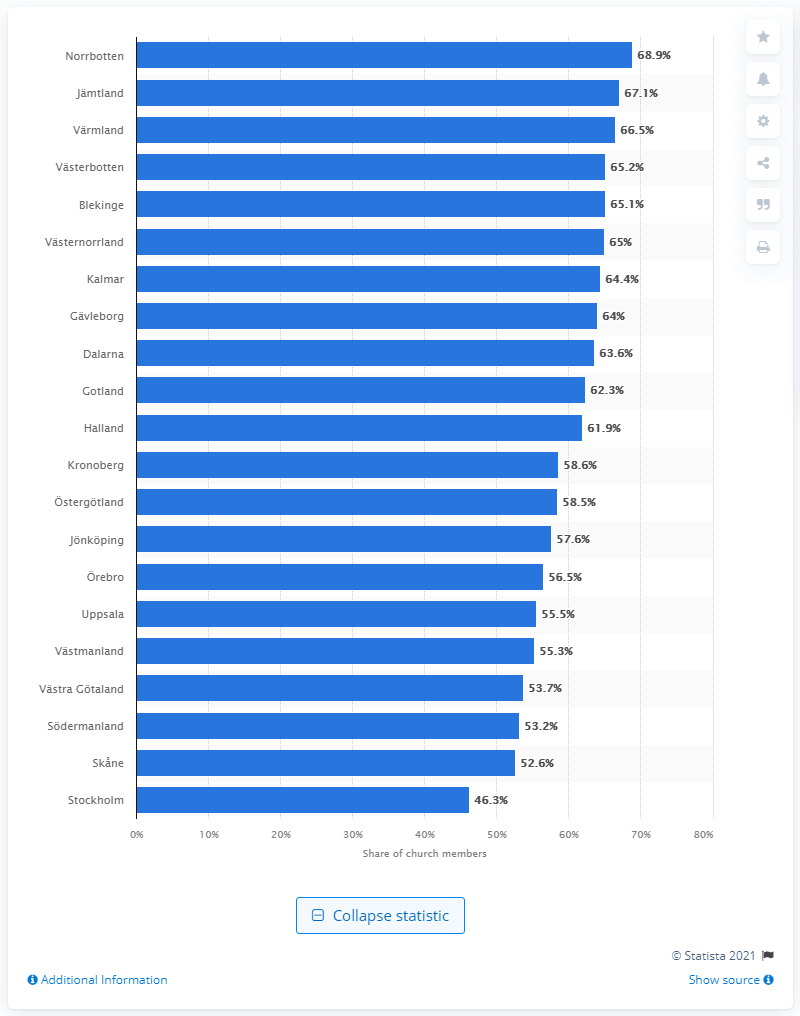Specify some key components in this picture. In 2020, the church membership percentage in Stockholm was 46.3%. Norrbotten county had the highest percentage of church members in Sweden in 2020. 